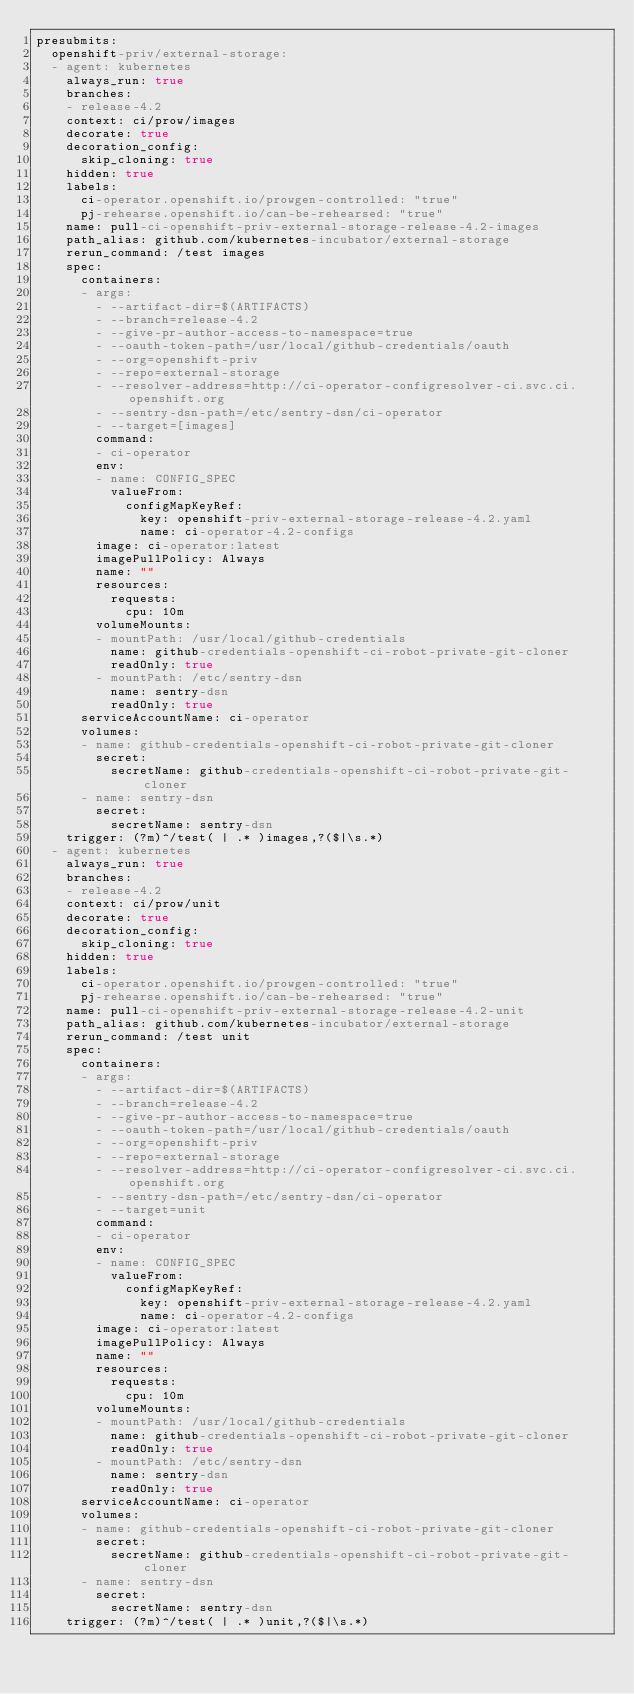Convert code to text. <code><loc_0><loc_0><loc_500><loc_500><_YAML_>presubmits:
  openshift-priv/external-storage:
  - agent: kubernetes
    always_run: true
    branches:
    - release-4.2
    context: ci/prow/images
    decorate: true
    decoration_config:
      skip_cloning: true
    hidden: true
    labels:
      ci-operator.openshift.io/prowgen-controlled: "true"
      pj-rehearse.openshift.io/can-be-rehearsed: "true"
    name: pull-ci-openshift-priv-external-storage-release-4.2-images
    path_alias: github.com/kubernetes-incubator/external-storage
    rerun_command: /test images
    spec:
      containers:
      - args:
        - --artifact-dir=$(ARTIFACTS)
        - --branch=release-4.2
        - --give-pr-author-access-to-namespace=true
        - --oauth-token-path=/usr/local/github-credentials/oauth
        - --org=openshift-priv
        - --repo=external-storage
        - --resolver-address=http://ci-operator-configresolver-ci.svc.ci.openshift.org
        - --sentry-dsn-path=/etc/sentry-dsn/ci-operator
        - --target=[images]
        command:
        - ci-operator
        env:
        - name: CONFIG_SPEC
          valueFrom:
            configMapKeyRef:
              key: openshift-priv-external-storage-release-4.2.yaml
              name: ci-operator-4.2-configs
        image: ci-operator:latest
        imagePullPolicy: Always
        name: ""
        resources:
          requests:
            cpu: 10m
        volumeMounts:
        - mountPath: /usr/local/github-credentials
          name: github-credentials-openshift-ci-robot-private-git-cloner
          readOnly: true
        - mountPath: /etc/sentry-dsn
          name: sentry-dsn
          readOnly: true
      serviceAccountName: ci-operator
      volumes:
      - name: github-credentials-openshift-ci-robot-private-git-cloner
        secret:
          secretName: github-credentials-openshift-ci-robot-private-git-cloner
      - name: sentry-dsn
        secret:
          secretName: sentry-dsn
    trigger: (?m)^/test( | .* )images,?($|\s.*)
  - agent: kubernetes
    always_run: true
    branches:
    - release-4.2
    context: ci/prow/unit
    decorate: true
    decoration_config:
      skip_cloning: true
    hidden: true
    labels:
      ci-operator.openshift.io/prowgen-controlled: "true"
      pj-rehearse.openshift.io/can-be-rehearsed: "true"
    name: pull-ci-openshift-priv-external-storage-release-4.2-unit
    path_alias: github.com/kubernetes-incubator/external-storage
    rerun_command: /test unit
    spec:
      containers:
      - args:
        - --artifact-dir=$(ARTIFACTS)
        - --branch=release-4.2
        - --give-pr-author-access-to-namespace=true
        - --oauth-token-path=/usr/local/github-credentials/oauth
        - --org=openshift-priv
        - --repo=external-storage
        - --resolver-address=http://ci-operator-configresolver-ci.svc.ci.openshift.org
        - --sentry-dsn-path=/etc/sentry-dsn/ci-operator
        - --target=unit
        command:
        - ci-operator
        env:
        - name: CONFIG_SPEC
          valueFrom:
            configMapKeyRef:
              key: openshift-priv-external-storage-release-4.2.yaml
              name: ci-operator-4.2-configs
        image: ci-operator:latest
        imagePullPolicy: Always
        name: ""
        resources:
          requests:
            cpu: 10m
        volumeMounts:
        - mountPath: /usr/local/github-credentials
          name: github-credentials-openshift-ci-robot-private-git-cloner
          readOnly: true
        - mountPath: /etc/sentry-dsn
          name: sentry-dsn
          readOnly: true
      serviceAccountName: ci-operator
      volumes:
      - name: github-credentials-openshift-ci-robot-private-git-cloner
        secret:
          secretName: github-credentials-openshift-ci-robot-private-git-cloner
      - name: sentry-dsn
        secret:
          secretName: sentry-dsn
    trigger: (?m)^/test( | .* )unit,?($|\s.*)
</code> 